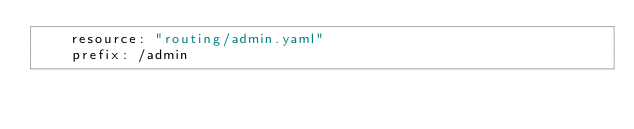Convert code to text. <code><loc_0><loc_0><loc_500><loc_500><_YAML_>    resource: "routing/admin.yaml"
    prefix: /admin
</code> 